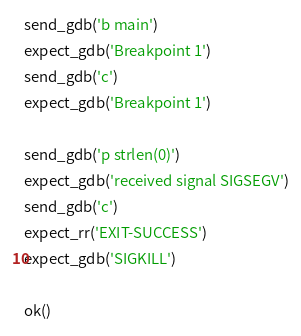<code> <loc_0><loc_0><loc_500><loc_500><_Python_>
send_gdb('b main')
expect_gdb('Breakpoint 1')
send_gdb('c')
expect_gdb('Breakpoint 1')

send_gdb('p strlen(0)')
expect_gdb('received signal SIGSEGV')
send_gdb('c')
expect_rr('EXIT-SUCCESS')
expect_gdb('SIGKILL')

ok()
</code> 